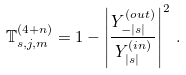Convert formula to latex. <formula><loc_0><loc_0><loc_500><loc_500>\mathbb { T } ^ { ( 4 + n ) } _ { s , j , m } = 1 - \left | \frac { Y ^ { ( o u t ) } _ { - | s | } } { Y ^ { ( i n ) } _ { | s | } } \right | ^ { 2 } \, .</formula> 